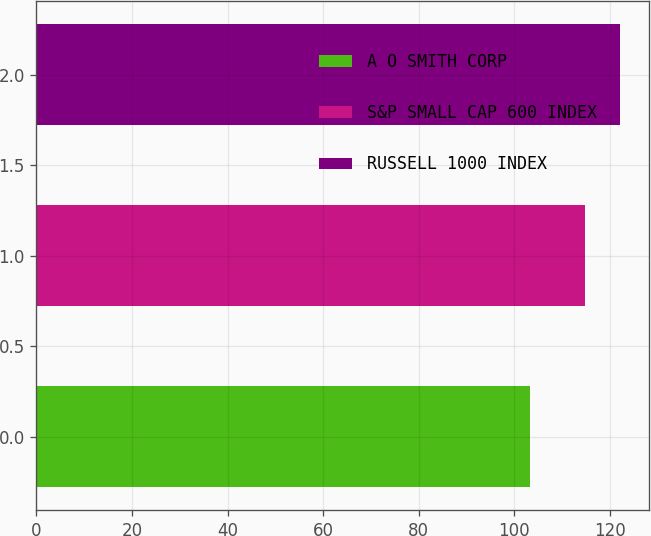Convert chart. <chart><loc_0><loc_0><loc_500><loc_500><bar_chart><fcel>A O SMITH CORP<fcel>S&P SMALL CAP 600 INDEX<fcel>RUSSELL 1000 INDEX<nl><fcel>103.3<fcel>114.8<fcel>122.1<nl></chart> 